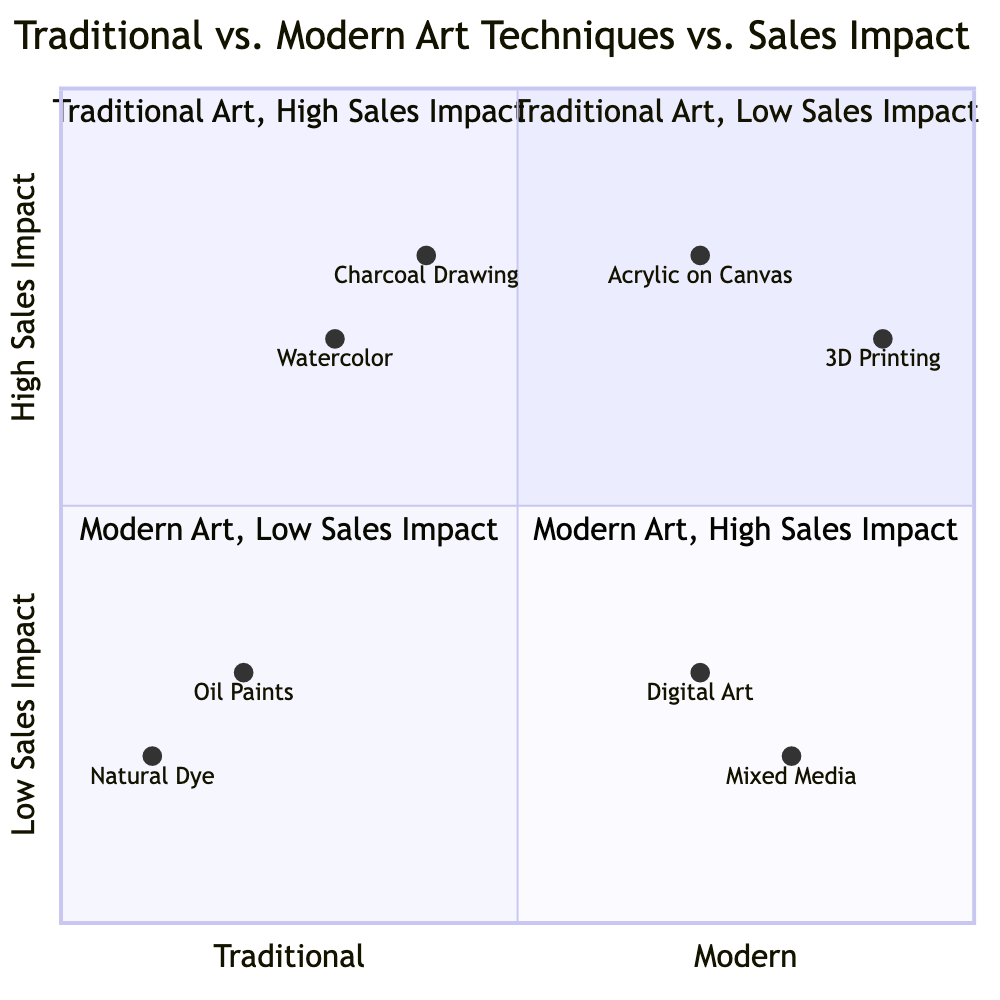What techniques are in the "Traditional Art, Low Sales Impact" quadrant? The "Traditional Art, Low Sales Impact" quadrant includes the techniques "Oil Paints" and "Natural Dye".
Answer: Oil Paints, Natural Dye In which quadrant is "Acrylic on Canvas" located? "Acrylic on Canvas" is located in the "Modern Art, High Sales Impact" quadrant.
Answer: Modern Art, High Sales Impact What is the position of "Digital Art" on the chart? "Digital Art" has coordinates [0.7, 0.3], indicating it's in the "Modern Art, Low Sales Impact" quadrant.
Answer: Modern Art, Low Sales Impact Which quadrant has the greatest sales impact associated with traditional techniques? The quadrant with the greatest sales impact associated with traditional techniques is "Traditional Art, High Sales Impact".
Answer: Traditional Art, High Sales Impact How many techniques are classified under "Modern Art, Low Sales Impact"? There are two techniques classified under "Modern Art, Low Sales Impact": "Digital Art" and "Mixed Media".
Answer: 2 Which traditional art technique has the highest sales impact? "Watercolor" has the highest sales impact among traditional art techniques, found in the "Traditional Art, High Sales Impact" quadrant.
Answer: Watercolor What real-world entity is associated with "Natural Dye"? The real-world entity associated with "Natural Dye" is "Aboriginal Dot Paintings".
Answer: Aboriginal Dot Paintings Is there a modern technique that has low sales impact but is visually appealing? "Digital Art" is a modern technique with low sales impact that can be visually appealing.
Answer: Digital Art What is the relationship between "Charcoal Drawing" and "Watercolor"? "Charcoal Drawing" has a higher sales impact than "Watercolor", indicating that sketches can be more valuable than paintings in certain cases.
Answer: Higher sales impact 